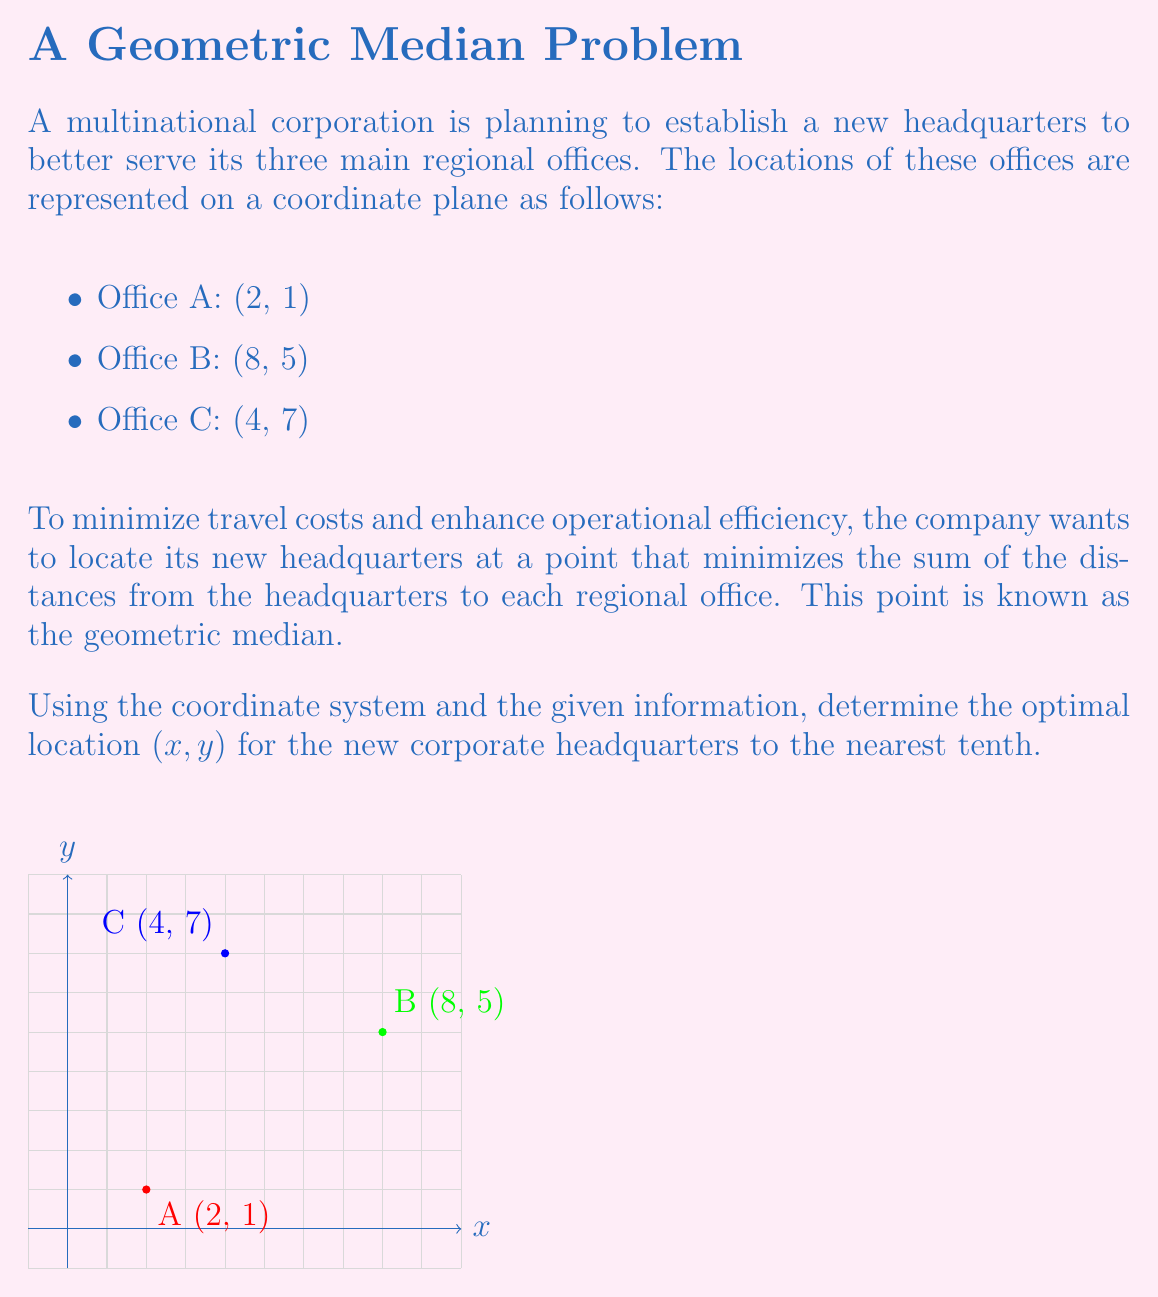Can you answer this question? To solve this problem, we'll use an iterative method known as the Weiszfeld algorithm, which is commonly used to find the geometric median. Here's the step-by-step process:

1) Start with an initial guess. We'll use the centroid of the triangle formed by the three points:
   $x_0 = \frac{2 + 8 + 4}{3} = 4.67$
   $y_0 = \frac{1 + 5 + 7}{3} = 4.33$

2) Apply the Weiszfeld algorithm iteratively:
   $$x_{n+1} = \frac{\sum_{i=1}^3 \frac{x_i}{d_i}}{\sum_{i=1}^3 \frac{1}{d_i}}$$
   $$y_{n+1} = \frac{\sum_{i=1}^3 \frac{y_i}{d_i}}{\sum_{i=1}^3 \frac{1}{d_i}}$$

   Where $(x_i, y_i)$ are the coordinates of each office, and $d_i$ is the distance from the current estimate to each office.

3) Calculate distances for the first iteration:
   $d_1 = \sqrt{(4.67-2)^2 + (4.33-1)^2} = 3.74$
   $d_2 = \sqrt{(4.67-8)^2 + (4.33-5)^2} = 3.37$
   $d_3 = \sqrt{(4.67-4)^2 + (4.33-7)^2} = 2.72$

4) Apply the formulas for the next iteration:
   $x_1 = \frac{\frac{2}{3.74} + \frac{8}{3.37} + \frac{4}{2.72}}{\frac{1}{3.74} + \frac{1}{3.37} + \frac{1}{2.72}} = 4.58$
   $y_1 = \frac{\frac{1}{3.74} + \frac{5}{3.37} + \frac{7}{2.72}}{\frac{1}{3.74} + \frac{1}{3.37} + \frac{1}{2.72}} = 4.40$

5) Repeat steps 3 and 4 until the values converge. After several iterations, we get:
   $x ≈ 4.6$
   $y ≈ 4.4$

These coordinates represent the optimal location for the new corporate headquarters, minimizing the total distance to all three regional offices.
Answer: (4.6, 4.4) 